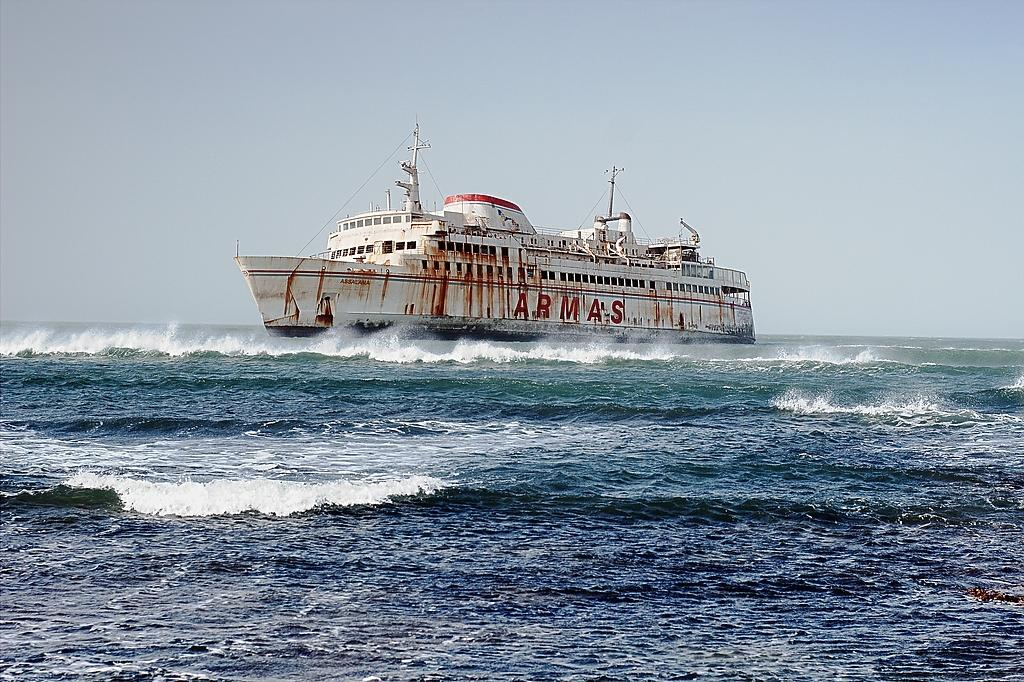What type of environment is depicted in the image? The image is an outside view. What body of water is visible in the image? There is an ocean in the image. What is floating on the water in the image? There is a ship in the water. What is visible above the water and the ship in the image? The sky is visible at the top of the image. What type of metal is the ship made of in the image? The facts provided do not mention the type of metal the ship is made of, so it cannot be determined from the image. How many ducks are swimming in the ocean in the image? There are no ducks visible in the image; it features an ocean and a ship. 